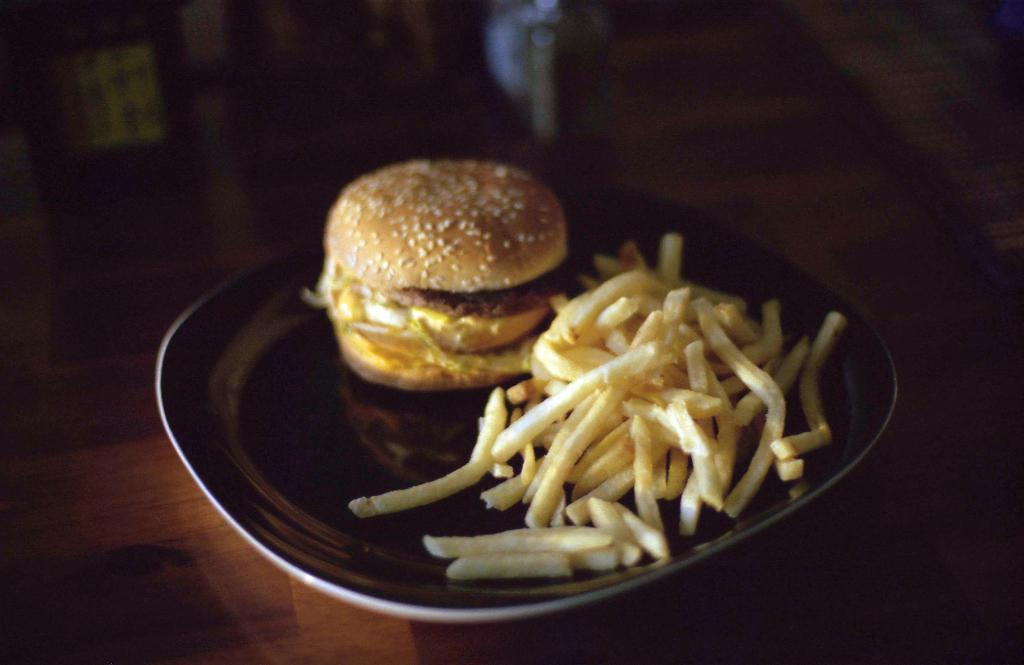What is on the plate that is visible in the image? The plate contains french fries. Besides french fries, what other food item can be seen in the image? There is a burger in the image. What is the color of the surface on which the plate is placed? The plate is on a brown surface. How would you describe the lighting in the image? The background of the image is a bit dark. How many cats are playing with a rifle in the image? There are no cats or rifles present in the image. 